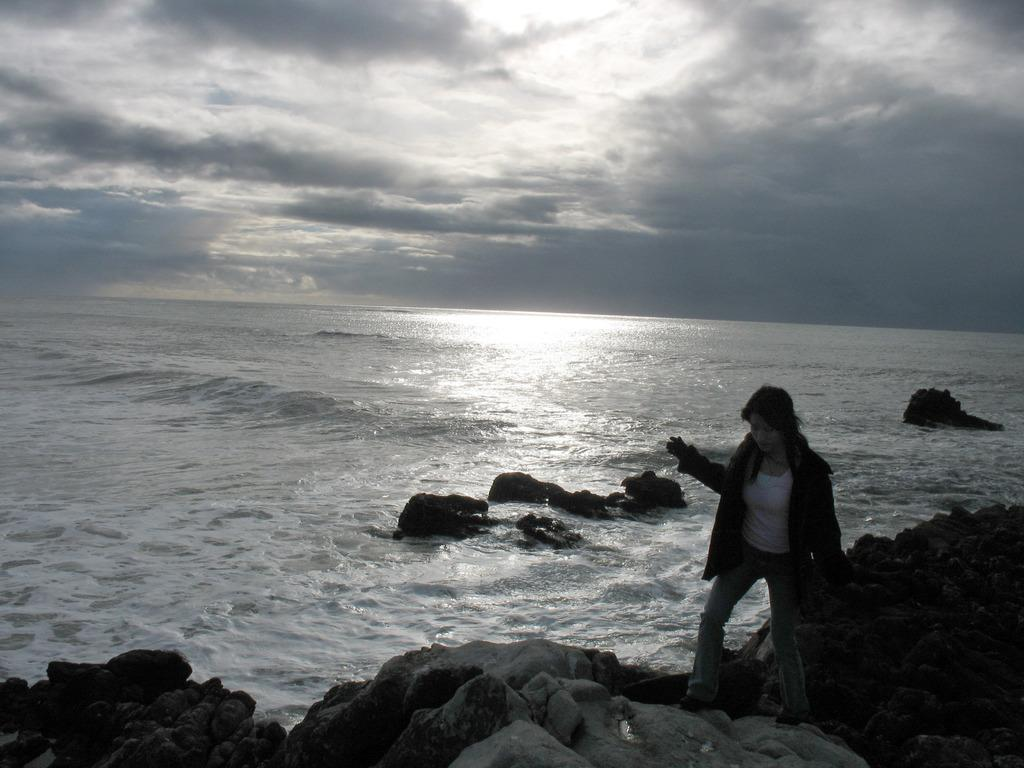What is the person in the image doing? The person is standing on a rock in the image. What can be seen in the background of the image? There are rocks and water visible in the background of the image. What else is visible in the background of the image? The sky is also visible in the background of the image. What type of cracker is the person eating while standing on the rock? There is no cracker present in the image, and the person is not eating anything. 